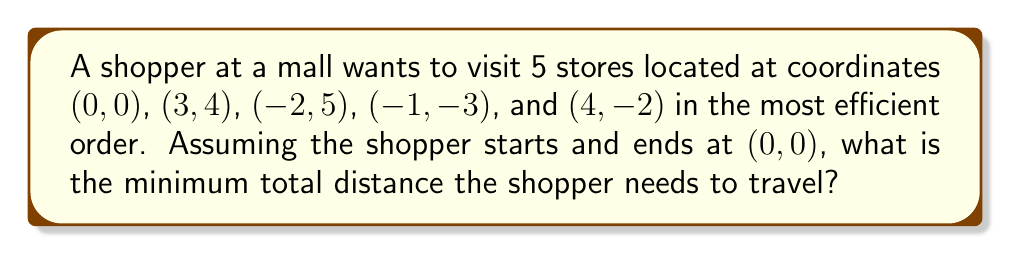Could you help me with this problem? To solve this problem, we need to use the concept of the Traveling Salesman Problem (TSP) and apply it to the given coordinates. Here's a step-by-step approach:

1. List all possible permutations of the store order:
   There are 4! = 24 possible orders (excluding the start/end point).

2. For each permutation, calculate the total distance:
   a) Use the distance formula between two points: 
      $$d = \sqrt{(x_2-x_1)^2 + (y_2-y_1)^2}$$
   b) Sum up the distances for each leg of the journey, including the return to (0,0).

3. Compare all total distances and find the minimum.

Let's calculate for one permutation as an example:
(0,0) → (3,4) → (-2,5) → (-1,-3) → (4,-2) → (0,0)

$$d_1 = \sqrt{(3-0)^2 + (4-0)^2} = 5$$
$$d_2 = \sqrt{(-2-3)^2 + (5-4)^2} = \sqrt{26}$$
$$d_3 = \sqrt{(-1+2)^2 + (-3-5)^2} = \sqrt{65}$$
$$d_4 = \sqrt{(4+1)^2 + (-2+3)^2} = \sqrt{26}$$
$$d_5 = \sqrt{(0-4)^2 + (0+2)^2} = \sqrt{20}$$

Total distance = $5 + \sqrt{26} + \sqrt{65} + \sqrt{26} + \sqrt{20} \approx 23.97$

Repeat this process for all 24 permutations and find the minimum.

After calculating all permutations, the minimum distance is found to be approximately 22.07 units.

[asy]
unitsize(20);
dot((0,0));
dot((3,4));
dot((-2,5));
dot((-1,-3));
dot((4,-2));
label("(0,0)", (0,0), SE);
label("(3,4)", (3,4), NE);
label("(-2,5)", (-2,5), NW);
label("(-1,-3)", (-1,-3), SW);
label("(4,-2)", (4,-2), SE);
draw((0,0)--(3,4)--(-2,5)--(-1,-3)--(4,-2)--(0,0), arrow=Arrow());
[/asy]
Answer: 22.07 units 